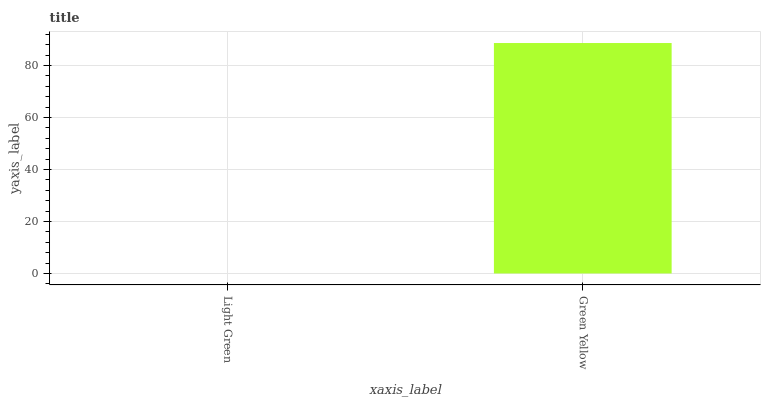Is Green Yellow the minimum?
Answer yes or no. No. Is Green Yellow greater than Light Green?
Answer yes or no. Yes. Is Light Green less than Green Yellow?
Answer yes or no. Yes. Is Light Green greater than Green Yellow?
Answer yes or no. No. Is Green Yellow less than Light Green?
Answer yes or no. No. Is Green Yellow the high median?
Answer yes or no. Yes. Is Light Green the low median?
Answer yes or no. Yes. Is Light Green the high median?
Answer yes or no. No. Is Green Yellow the low median?
Answer yes or no. No. 